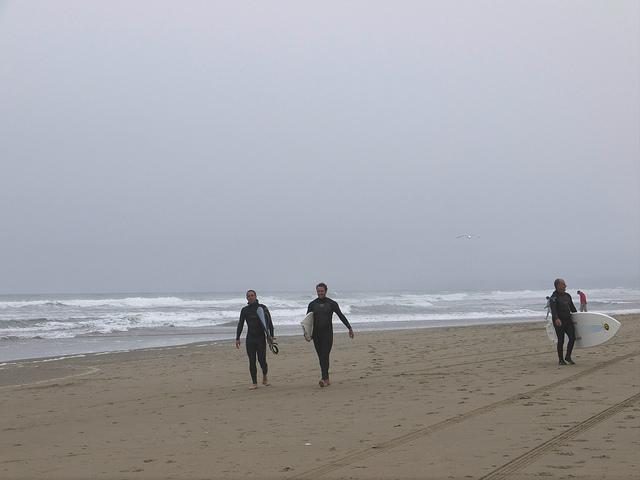How many people do you see in this picture?
Give a very brief answer. 4. How many horses are on the beach?
Give a very brief answer. 0. How many people can be seen?
Give a very brief answer. 4. How many different activities are people in the picture engaged in?
Give a very brief answer. 1. 